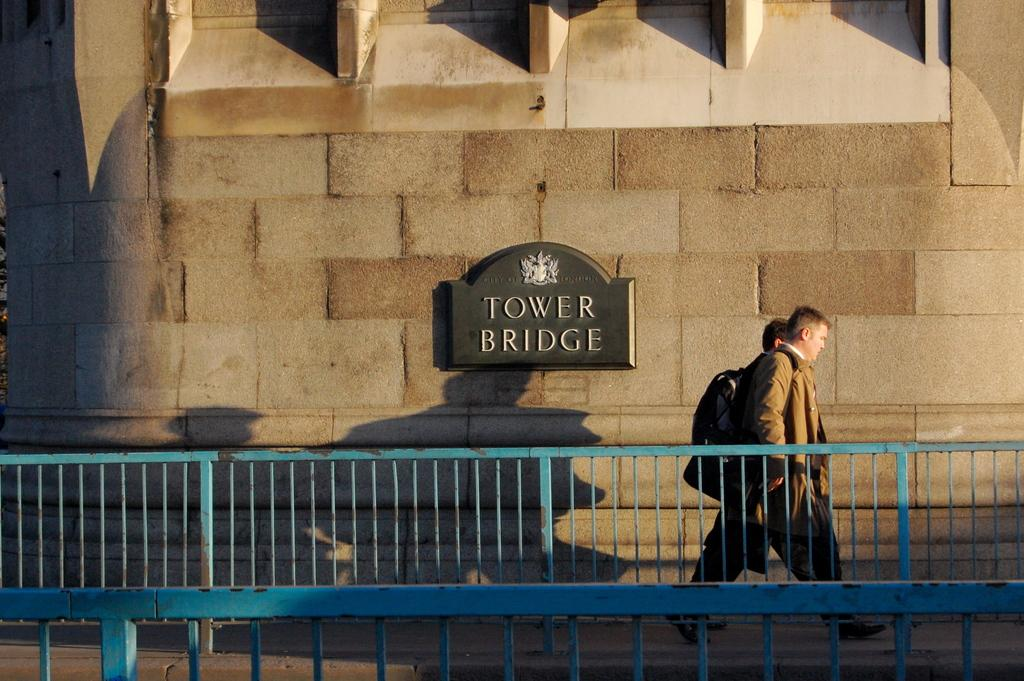What are the people in the image doing? The people in the image are walking on the bridge. What structure can be seen in the background of the image? There is a building in the image. What information is provided on the building? The building has the text "Tower Bridge" on its grid. What type of pail is hanging from the bridge in the image? There is no pail present in the image. How many hearts can be seen on the building in the image? There are no hearts depicted on the building in the image; it only has the text "Tower Bridge" on its grid. 